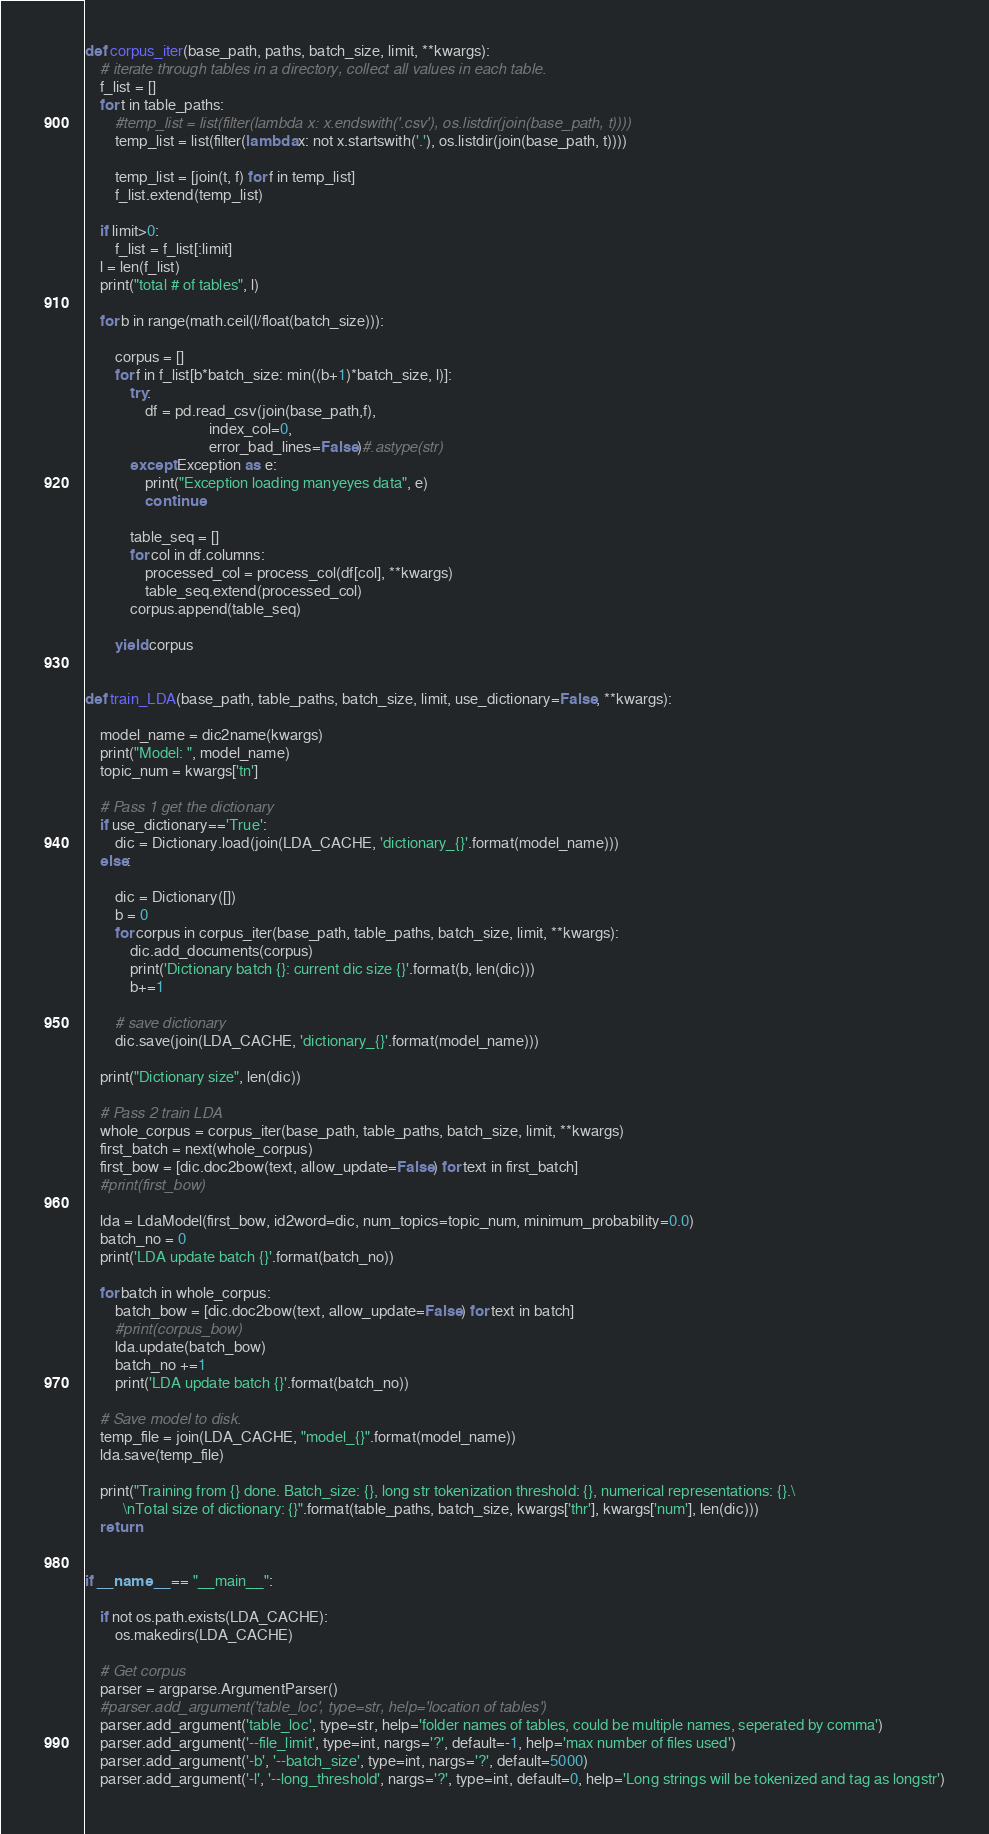Convert code to text. <code><loc_0><loc_0><loc_500><loc_500><_Python_>
def corpus_iter(base_path, paths, batch_size, limit, **kwargs):
    # iterate through tables in a directory, collect all values in each table.
    f_list = []
    for t in table_paths:
        #temp_list = list(filter(lambda x: x.endswith('.csv'), os.listdir(join(base_path, t))))
        temp_list = list(filter(lambda x: not x.startswith('.'), os.listdir(join(base_path, t))))

        temp_list = [join(t, f) for f in temp_list]
        f_list.extend(temp_list)

    if limit>0:
        f_list = f_list[:limit]    
    l = len(f_list)
    print("total # of tables", l)

    for b in range(math.ceil(l/float(batch_size))):    

        corpus = []
        for f in f_list[b*batch_size: min((b+1)*batch_size, l)]:
            try:
                df = pd.read_csv(join(base_path,f),
                                 index_col=0, 
                                 error_bad_lines=False)#.astype(str) 
            except Exception as e:
                print("Exception loading manyeyes data", e)
                continue
                
            table_seq = []
            for col in df.columns:
                processed_col = process_col(df[col], **kwargs)
                table_seq.extend(processed_col)
            corpus.append(table_seq)

        yield corpus
             

def train_LDA(base_path, table_paths, batch_size, limit, use_dictionary=False, **kwargs):

    model_name = dic2name(kwargs)
    print("Model: ", model_name)
    topic_num = kwargs['tn']

    # Pass 1 get the dictionary
    if use_dictionary=='True':
        dic = Dictionary.load(join(LDA_CACHE, 'dictionary_{}'.format(model_name)))
    else:

        dic = Dictionary([])
        b = 0
        for corpus in corpus_iter(base_path, table_paths, batch_size, limit, **kwargs):
            dic.add_documents(corpus)
            print('Dictionary batch {}: current dic size {}'.format(b, len(dic)))
            b+=1
            
        # save dictionary
        dic.save(join(LDA_CACHE, 'dictionary_{}'.format(model_name)))

    print("Dictionary size", len(dic))
    
    # Pass 2 train LDA
    whole_corpus = corpus_iter(base_path, table_paths, batch_size, limit, **kwargs)
    first_batch = next(whole_corpus)
    first_bow = [dic.doc2bow(text, allow_update=False) for text in first_batch]
    #print(first_bow)

    lda = LdaModel(first_bow, id2word=dic, num_topics=topic_num, minimum_probability=0.0)
    batch_no = 0
    print('LDA update batch {}'.format(batch_no))

    for batch in whole_corpus:
        batch_bow = [dic.doc2bow(text, allow_update=False) for text in batch]
        #print(corpus_bow)
        lda.update(batch_bow)
        batch_no +=1
        print('LDA update batch {}'.format(batch_no))
    
    # Save model to disk.
    temp_file = join(LDA_CACHE, "model_{}".format(model_name))
    lda.save(temp_file)
    
    print("Training from {} done. Batch_size: {}, long str tokenization threshold: {}, numerical representations: {}.\
          \nTotal size of dictionary: {}".format(table_paths, batch_size, kwargs['thr'], kwargs['num'], len(dic)))
    return


if __name__ == "__main__":

    if not os.path.exists(LDA_CACHE):
        os.makedirs(LDA_CACHE)

    # Get corpus
    parser = argparse.ArgumentParser()
    #parser.add_argument('table_loc', type=str, help='location of tables')
    parser.add_argument('table_loc', type=str, help='folder names of tables, could be multiple names, seperated by comma')
    parser.add_argument('--file_limit', type=int, nargs='?', default=-1, help='max number of files used')
    parser.add_argument('-b', '--batch_size', type=int, nargs='?', default=5000)
    parser.add_argument('-l', '--long_threshold', nargs='?', type=int, default=0, help='Long strings will be tokenized and tag as longstr')</code> 